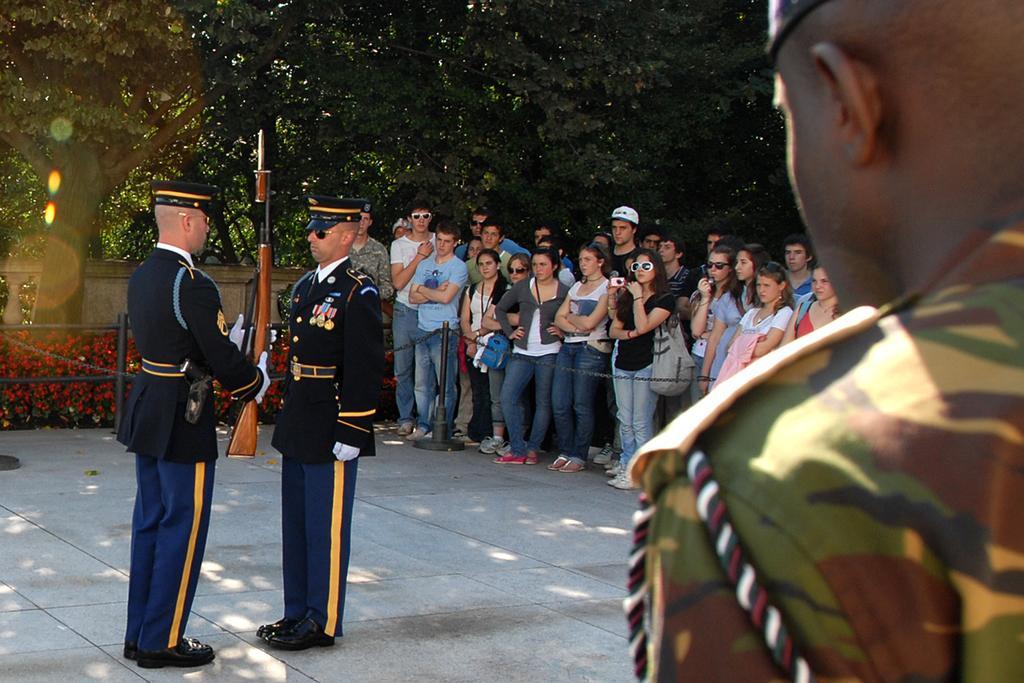Please provide a concise description of this image. In the image we can see there are people standing and they are holding rifle in their hand and behind there are other people standing. There are lot of trees at the back. 